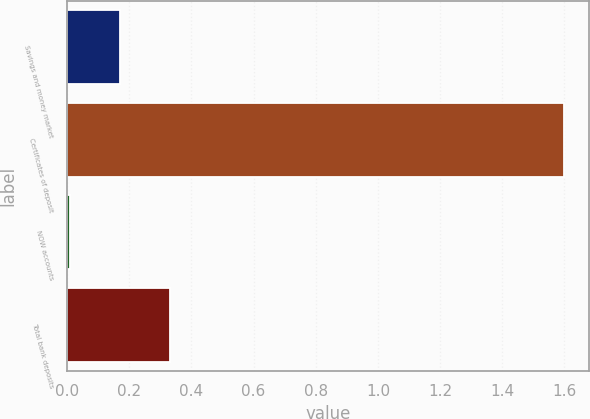Convert chart to OTSL. <chart><loc_0><loc_0><loc_500><loc_500><bar_chart><fcel>Savings and money market<fcel>Certificates of deposit<fcel>NOW accounts<fcel>Total bank deposits<nl><fcel>0.17<fcel>1.6<fcel>0.01<fcel>0.33<nl></chart> 